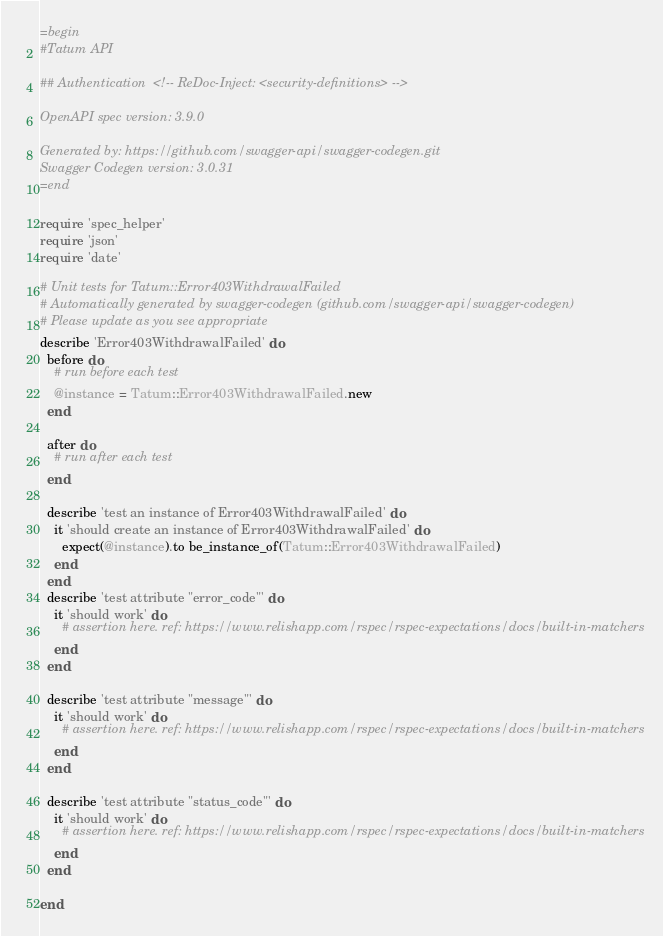<code> <loc_0><loc_0><loc_500><loc_500><_Ruby_>=begin
#Tatum API

## Authentication  <!-- ReDoc-Inject: <security-definitions> -->

OpenAPI spec version: 3.9.0

Generated by: https://github.com/swagger-api/swagger-codegen.git
Swagger Codegen version: 3.0.31
=end

require 'spec_helper'
require 'json'
require 'date'

# Unit tests for Tatum::Error403WithdrawalFailed
# Automatically generated by swagger-codegen (github.com/swagger-api/swagger-codegen)
# Please update as you see appropriate
describe 'Error403WithdrawalFailed' do
  before do
    # run before each test
    @instance = Tatum::Error403WithdrawalFailed.new
  end

  after do
    # run after each test
  end

  describe 'test an instance of Error403WithdrawalFailed' do
    it 'should create an instance of Error403WithdrawalFailed' do
      expect(@instance).to be_instance_of(Tatum::Error403WithdrawalFailed)
    end
  end
  describe 'test attribute "error_code"' do
    it 'should work' do
      # assertion here. ref: https://www.relishapp.com/rspec/rspec-expectations/docs/built-in-matchers
    end
  end

  describe 'test attribute "message"' do
    it 'should work' do
      # assertion here. ref: https://www.relishapp.com/rspec/rspec-expectations/docs/built-in-matchers
    end
  end

  describe 'test attribute "status_code"' do
    it 'should work' do
      # assertion here. ref: https://www.relishapp.com/rspec/rspec-expectations/docs/built-in-matchers
    end
  end

end
</code> 